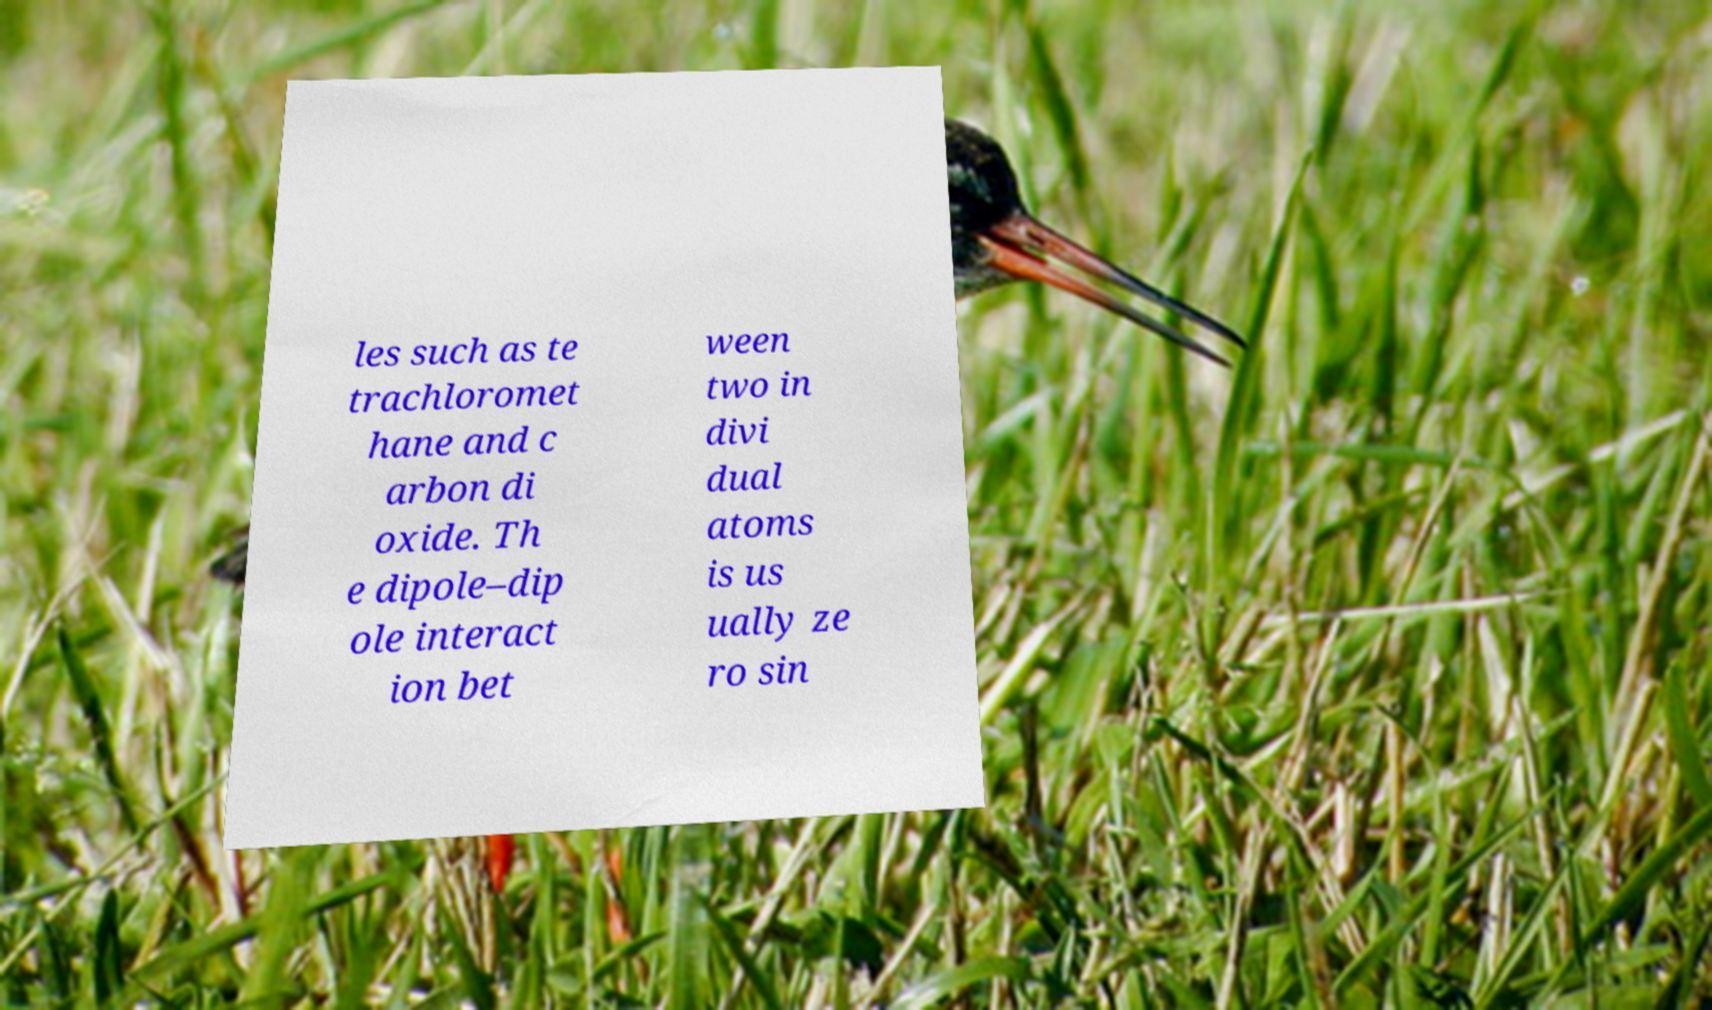Can you read and provide the text displayed in the image?This photo seems to have some interesting text. Can you extract and type it out for me? les such as te trachloromet hane and c arbon di oxide. Th e dipole–dip ole interact ion bet ween two in divi dual atoms is us ually ze ro sin 